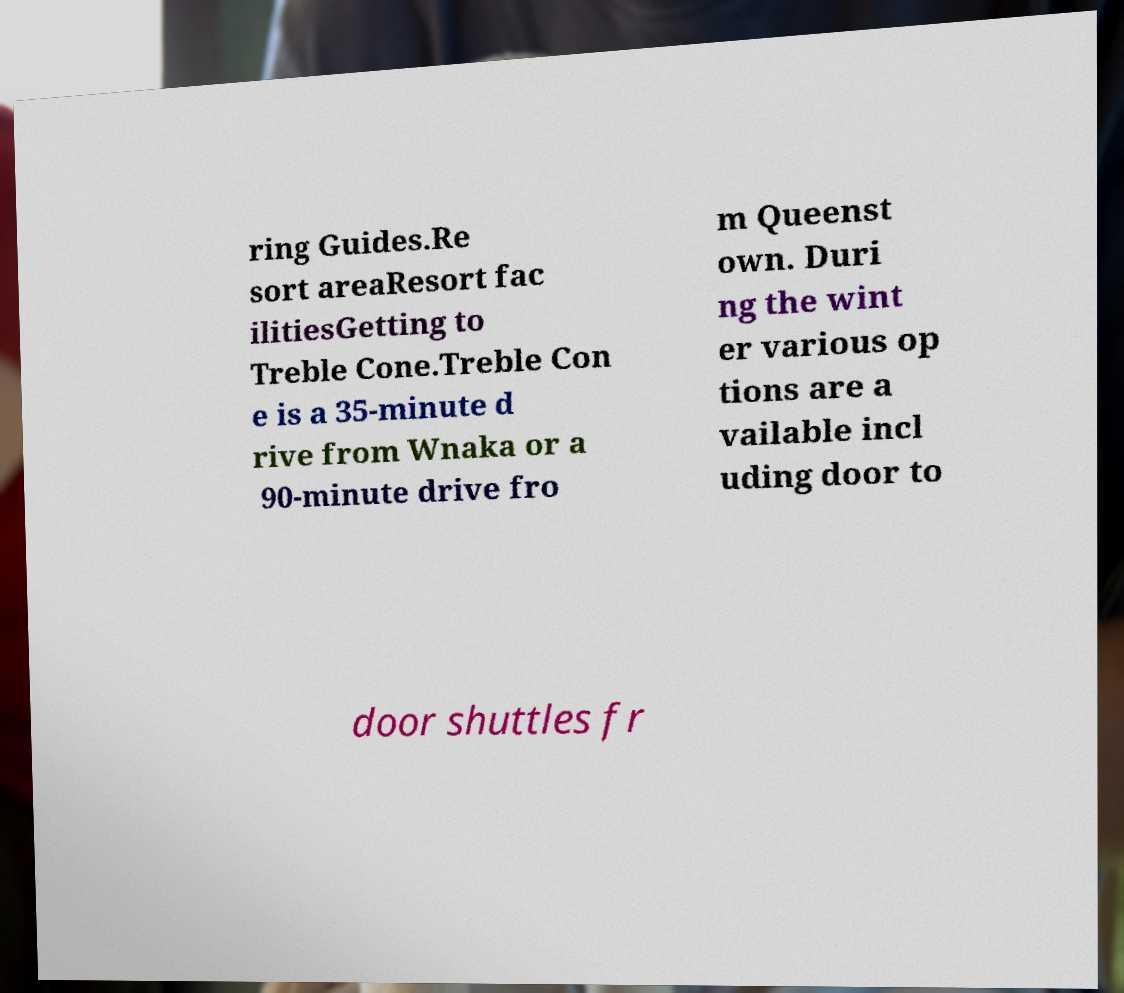Please identify and transcribe the text found in this image. ring Guides.Re sort areaResort fac ilitiesGetting to Treble Cone.Treble Con e is a 35-minute d rive from Wnaka or a 90-minute drive fro m Queenst own. Duri ng the wint er various op tions are a vailable incl uding door to door shuttles fr 